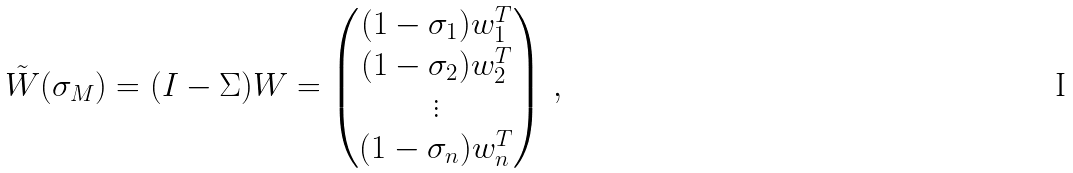<formula> <loc_0><loc_0><loc_500><loc_500>\tilde { W } ( \sigma _ { M } ) = ( I - \Sigma ) W = \begin{pmatrix} ( 1 - \sigma _ { 1 } ) w _ { 1 } ^ { T } \\ ( 1 - \sigma _ { 2 } ) w _ { 2 } ^ { T } \\ \vdots \\ ( 1 - \sigma _ { n } ) w _ { n } ^ { T } \end{pmatrix} \, ,</formula> 